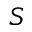Convert formula to latex. <formula><loc_0><loc_0><loc_500><loc_500>S</formula> 